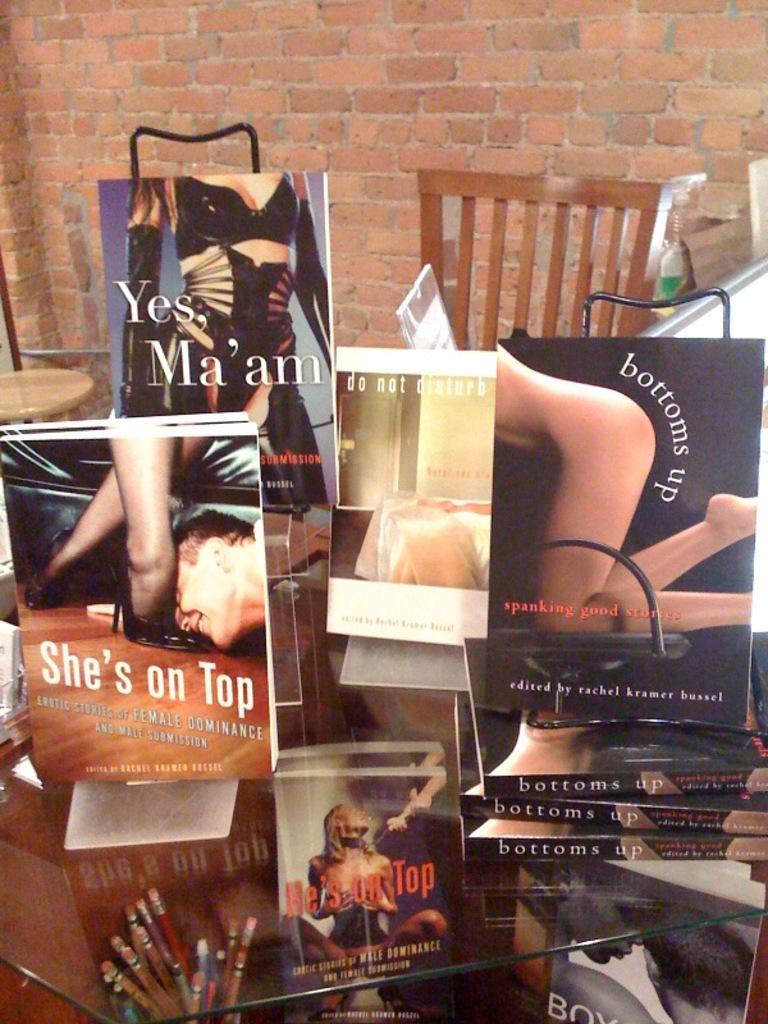What is the main piece of furniture in the image? There is a table in the image. What items can be seen on the table? There are many books and pencils on the table. What type of wall is visible in the background of the image? There is a brick wall in the background of the image. What other piece of furniture is present in the image? There is a wooden chair in the image. How many pigs are sitting on the wooden chair in the image? There are no pigs present in the image; it only features a table, books, pencils, a brick wall, and a wooden chair. 